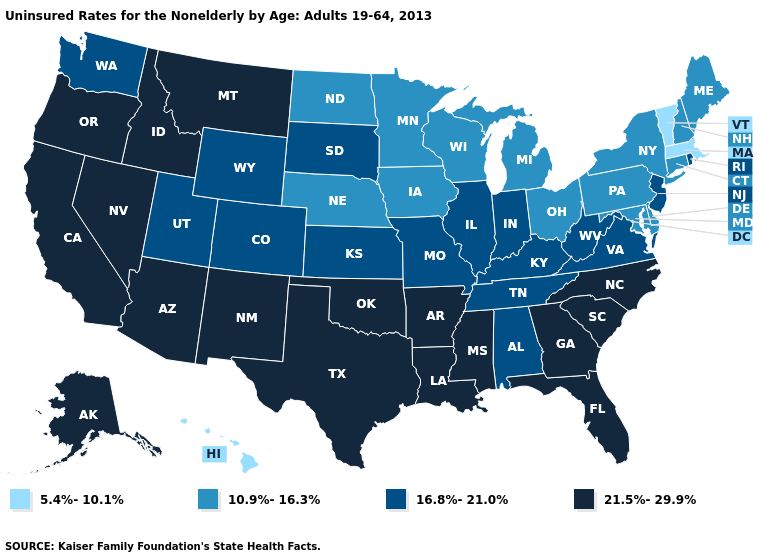What is the value of Tennessee?
Concise answer only. 16.8%-21.0%. Name the states that have a value in the range 21.5%-29.9%?
Be succinct. Alaska, Arizona, Arkansas, California, Florida, Georgia, Idaho, Louisiana, Mississippi, Montana, Nevada, New Mexico, North Carolina, Oklahoma, Oregon, South Carolina, Texas. What is the value of North Dakota?
Write a very short answer. 10.9%-16.3%. Does Nevada have the highest value in the USA?
Give a very brief answer. Yes. What is the value of South Carolina?
Quick response, please. 21.5%-29.9%. Does Hawaii have the lowest value in the USA?
Be succinct. Yes. Is the legend a continuous bar?
Give a very brief answer. No. What is the lowest value in states that border New York?
Give a very brief answer. 5.4%-10.1%. What is the lowest value in states that border Indiana?
Quick response, please. 10.9%-16.3%. Does the map have missing data?
Give a very brief answer. No. What is the value of North Carolina?
Write a very short answer. 21.5%-29.9%. What is the lowest value in the USA?
Be succinct. 5.4%-10.1%. Does Rhode Island have the highest value in the Northeast?
Answer briefly. Yes. How many symbols are there in the legend?
Keep it brief. 4. Among the states that border Utah , which have the highest value?
Give a very brief answer. Arizona, Idaho, Nevada, New Mexico. 